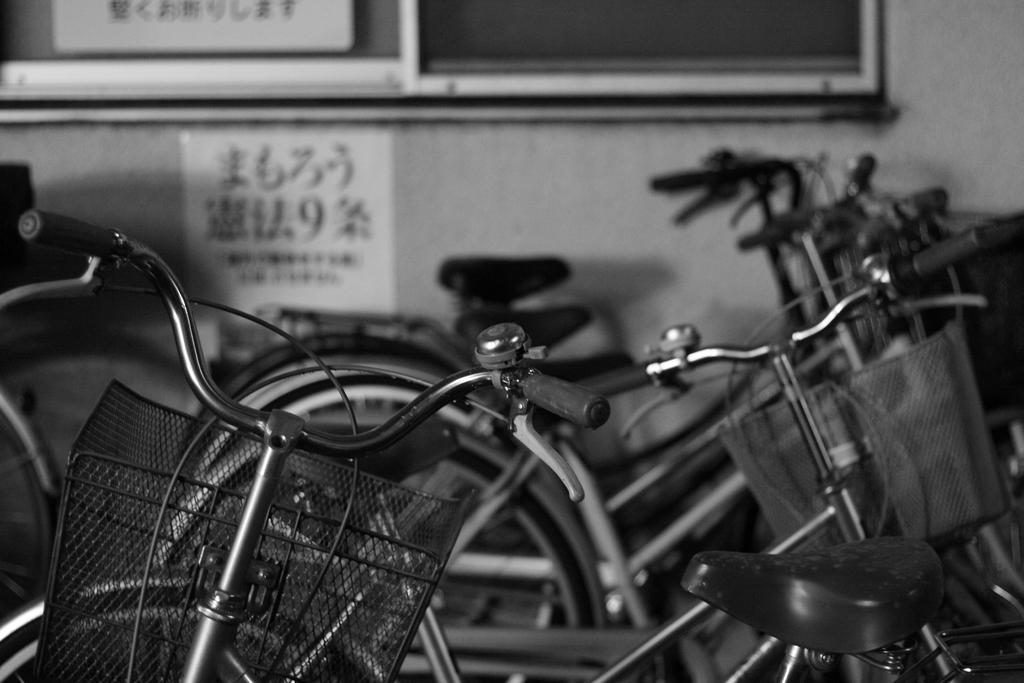What type of vehicles are in the picture? There are bicycles in the picture. What can be seen in the background of the picture? There is a wall in the background of the picture. What color scheme is used in the picture? The picture is black and white in color. What language is being spoken by the bicycles in the image? Bicycles do not speak any language, as they are inanimate objects. 